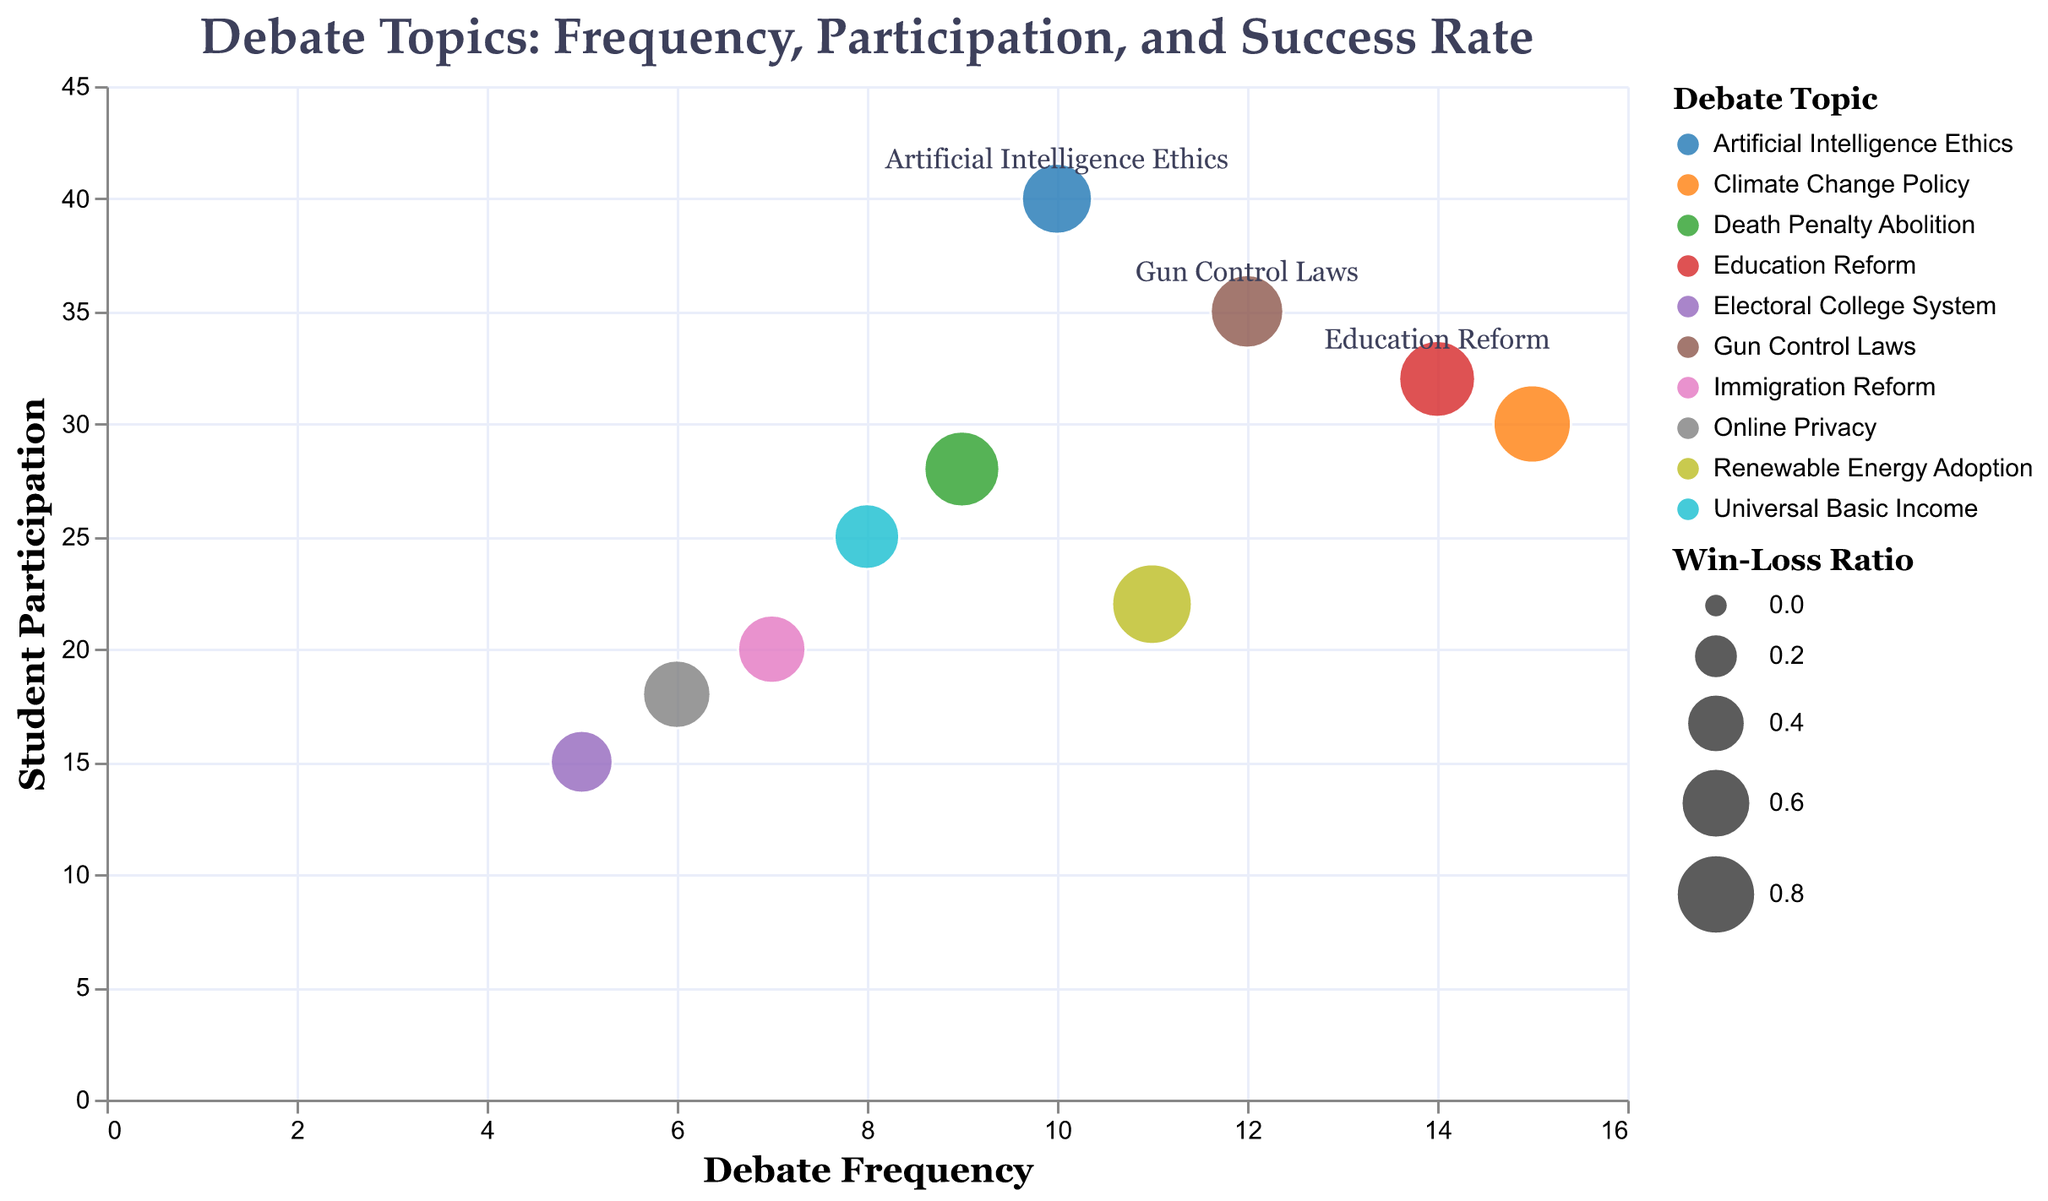What is the title of the chart? The title of a chart is usually placed prominently at the top and it summarizes the content.
Answer: Debate Topics: Frequency, Participation, and Success Rate What is the debate topic with the highest frequency? Look for the bubble with the highest value on the x-axis which represents Frequency.
Answer: Climate Change Policy Which debate topic has the highest win-loss ratio? Identify the bubble with the largest size since size represents the win-loss ratio.
Answer: Renewable Energy Adoption How many data points are plotted in the chart? Count the number of bubbles in the bubble chart.
Answer: 10 What’s the frequency range for the debate topics in the chart? Look at the x-axis to find the minimum and maximum values it covers.
Answer: 0 to 16 Which debate topic has the lowest student participation? Look for the bubble that is lowest on the y-axis which represents Student Participation.
Answer: Electoral College System If you combined the student participation for Climate Change Policy and Gun Control Laws, what would be the result? Find the y-values for those topics and add them together (30 + 35).
Answer: 65 For which debate topic is student participation higher: Artificial Intelligence Ethics or Education Reform? Compare the y-values for both Artificial Intelligence Ethics and Education Reform.
Answer: Artificial Intelligence Ethics Compare the win-loss ratios of Death Penalty Abolition and Education Reform. Which one is higher? Look at the relative bubble sizes for both Death Penalty Abolition and Education Reform.
Answer: Death Penalty Abolition Which debate topic falls at the intersection of a frequency of 6 and a student participation of 18? Locate the bubble that intersects the x value of 6 and the y value of 18.
Answer: Online Privacy 